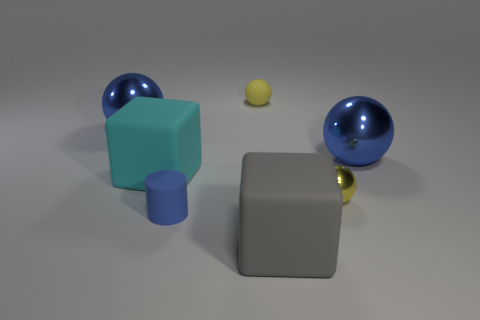Add 1 small yellow shiny things. How many objects exist? 8 Add 1 cubes. How many cubes exist? 3 Subtract all cyan blocks. How many blocks are left? 1 Subtract all yellow matte spheres. How many spheres are left? 3 Subtract 1 blue cylinders. How many objects are left? 6 Subtract all cylinders. How many objects are left? 6 Subtract 2 blocks. How many blocks are left? 0 Subtract all gray balls. Subtract all gray cylinders. How many balls are left? 4 Subtract all yellow spheres. How many cyan blocks are left? 1 Subtract all blue matte cylinders. Subtract all gray objects. How many objects are left? 5 